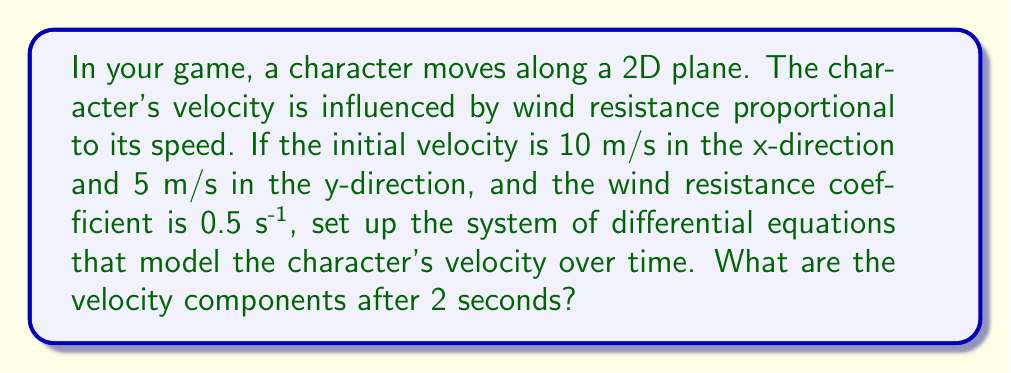Can you answer this question? Let's approach this step-by-step:

1) Let $v_x$ and $v_y$ be the velocity components in the x and y directions, respectively.

2) The wind resistance is proportional to the speed and opposite to the direction of motion. This gives us the following system of differential equations:

   $$\frac{dv_x}{dt} = -kv_x$$
   $$\frac{dv_y}{dt} = -kv_y$$

   where $k = 0.5$ s^(-1) is the wind resistance coefficient.

3) The general solution for these equations is:

   $$v_x(t) = v_{x0}e^{-kt}$$
   $$v_y(t) = v_{y0}e^{-kt}$$

   where $v_{x0}$ and $v_{y0}$ are the initial velocities.

4) Given the initial conditions:
   $v_{x0} = 10$ m/s
   $v_{y0} = 5$ m/s

5) Substituting these into our solution:

   $$v_x(t) = 10e^{-0.5t}$$
   $$v_y(t) = 5e^{-0.5t}$$

6) To find the velocity components after 2 seconds, we evaluate these at $t = 2$:

   $$v_x(2) = 10e^{-0.5(2)} = 10e^{-1} \approx 3.68 \text{ m/s}$$
   $$v_y(2) = 5e^{-0.5(2)} = 5e^{-1} \approx 1.84 \text{ m/s}$$
Answer: $(3.68, 1.84)$ m/s 